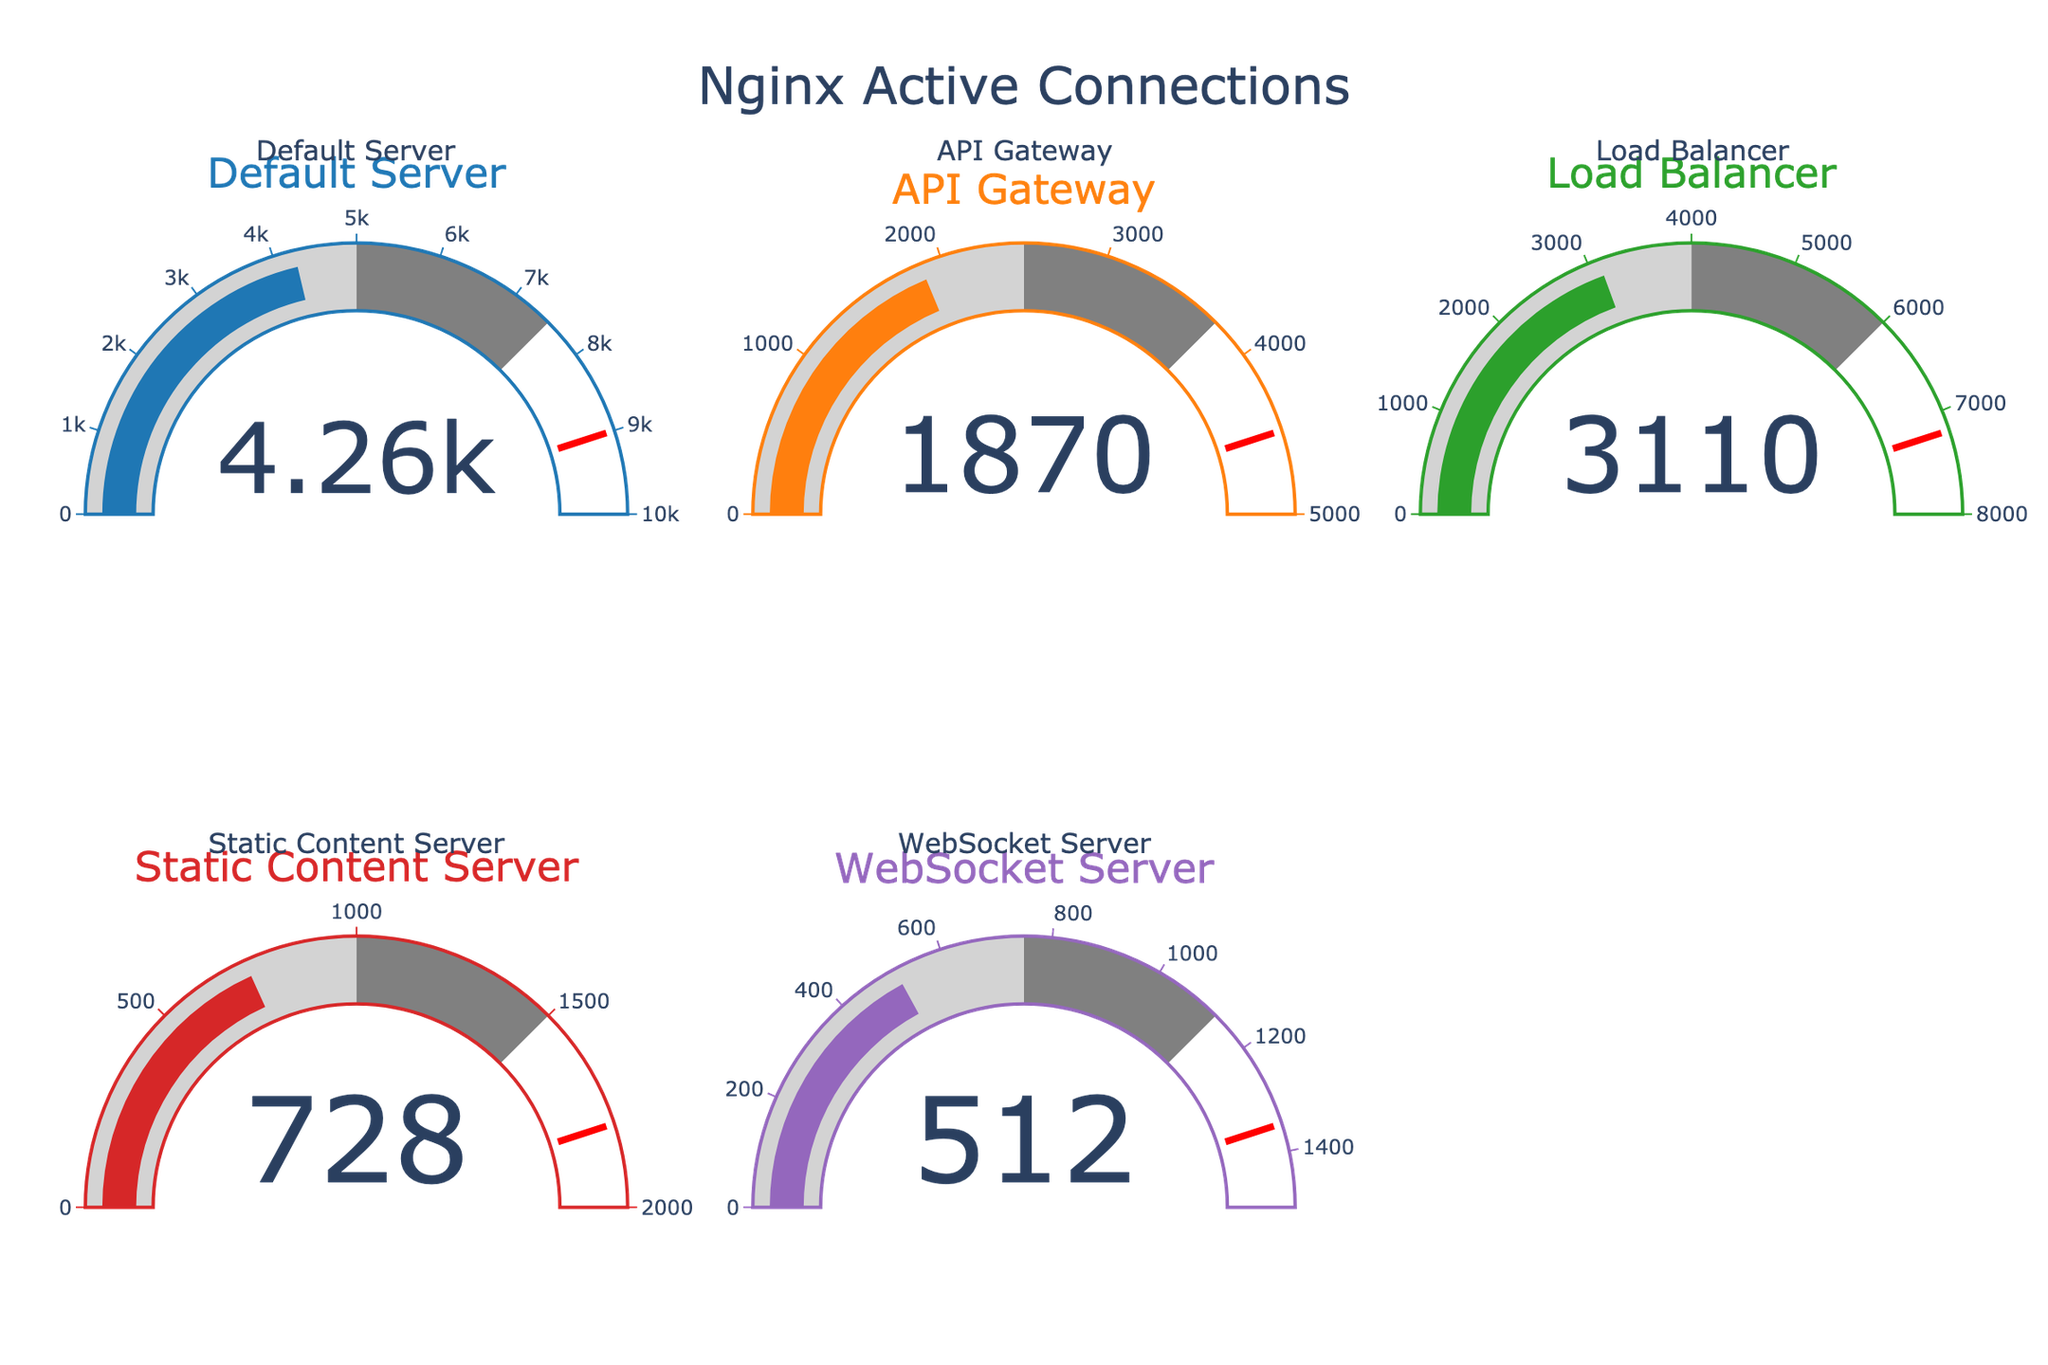What's the highest value among the Nginx servers? The values are: 4256, 1872, 3105, 728, and 512. The highest value is 4256.
Answer: 4256 Which server has the lowest number of active connections? The values are: 4256, 1872, 3105, 728, and 512. The lowest value is 512, which corresponds to the WebSocket Server.
Answer: WebSocket Server How many servers have more than 3000 active connections? Comparing the values of all servers: 4256, 1872, 3105, 728, and 512. Both Default Server and Load Balancer have more than 3000 active connections.
Answer: 2 Which server has the most room before reaching its maximum capacity? The capacities and current values are: Default Server (10000-4256), API Gateway (5000-1872), Load Balancer (8000-3105), Static Content Server (2000-728), and WebSocket Server (1500-512). The Default Server has the most room with a difference of 5744.
Answer: Default Server What is the combined number of active connections for the API Gateway and Load Balancer? The values for API Gateway and Load Balancer are 1872 and 3105 respectively. Their combined number of active connections is 1872 + 3105.
Answer: 4977 Which server is closest to reaching 75% of its maximum capacity? Calculating 75% of each server's capacity: Default Server (7500), API Gateway (3750), Load Balancer (6000), Static Content Server (1500), and WebSocket Server (1125). The closest to 75% is WebSocket Server with 512 compared to its 75% mark of 1125.
Answer: WebSocket Server Do any servers currently exceed half of their maximum capacity? All values are compared: 4256 (Default Server), 1872 (API Gateway), 3105 (Load Balancer), 728 (Static Content Server), and 512 (WebSocket Server). The Default Server, API Gateway, and Load Balancer exceed half of their maximum capacities.
Answer: Yes What's the average number of active connections for all servers? The total number of active connections is 4256 + 1872 + 3105 + 728 + 512 = 10473. The average is 10473 divided by 5.
Answer: 2094.6 Which server is closest to its threshold value of 90% capacity? Calculating 90% of each server's capacity: Default Server (9000), API Gateway (4500), Load Balancer (7200), Static Content Server (1800), and WebSocket Server (1350). Load Balancer, which is 3105, is closest to its 90% mark of 7200.
Answer: Load Balancer 